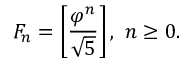Convert formula to latex. <formula><loc_0><loc_0><loc_500><loc_500>F _ { n } = \left [ { \frac { \varphi ^ { n } } { \sqrt { 5 } } } \right ] , \ n \geq 0 .</formula> 